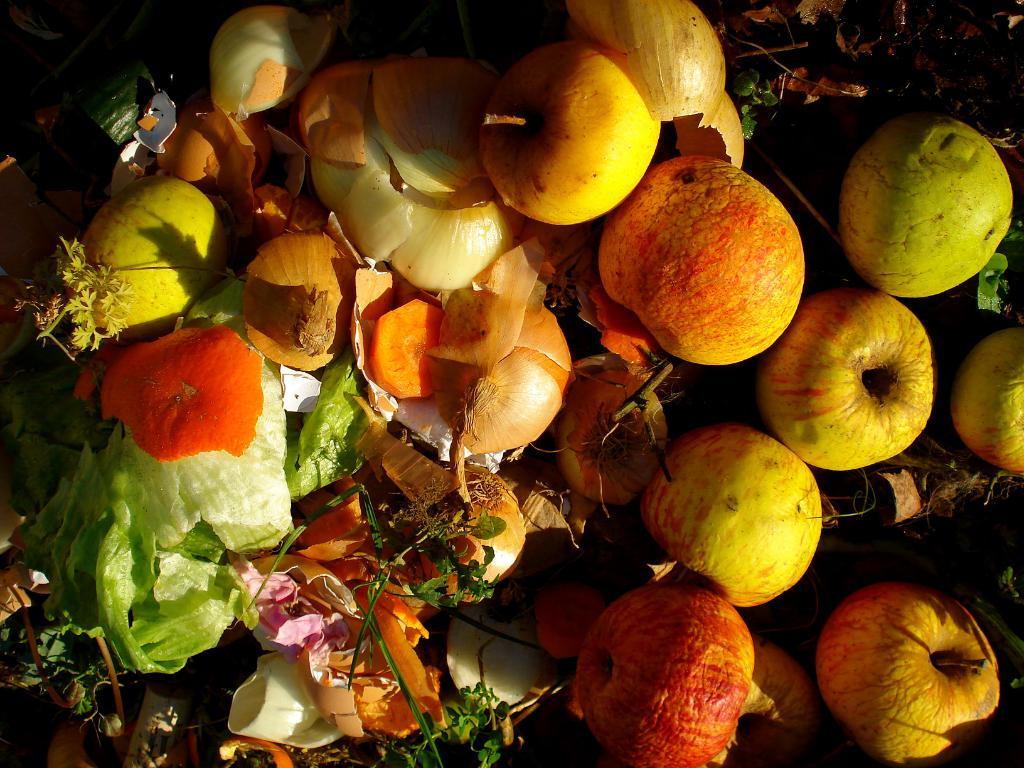What types of food items are present in the image? There are fruits and vegetables in the image. Can you describe the appearance of the fruits and vegetables? The fruits and vegetables are colorful in the image. What is the background color in the image? There is a black background in the image. What type of skirt is visible in the image? There is no skirt present in the image; it features fruits and vegetables on a black background. How does the cabbage move in the image? There is no cabbage present in the image, and therefore no motion can be observed. 